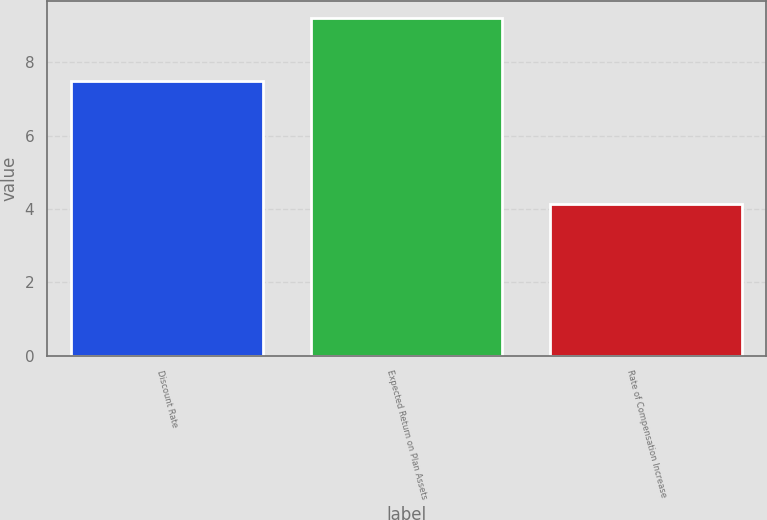Convert chart. <chart><loc_0><loc_0><loc_500><loc_500><bar_chart><fcel>Discount Rate<fcel>Expected Return on Plan Assets<fcel>Rate of Compensation Increase<nl><fcel>7.5<fcel>9.2<fcel>4.15<nl></chart> 